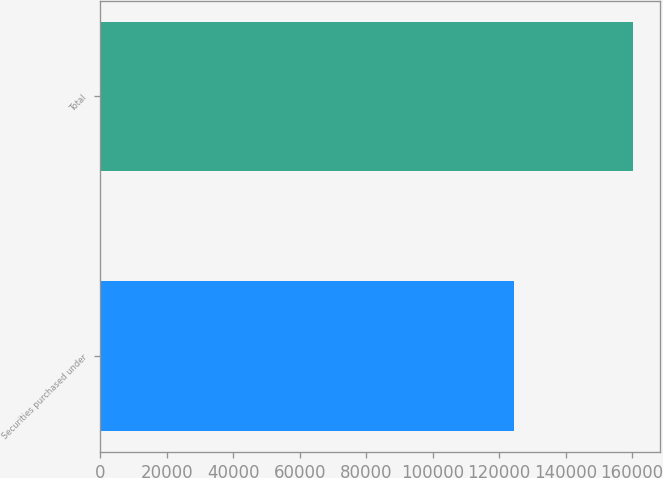Convert chart. <chart><loc_0><loc_0><loc_500><loc_500><bar_chart><fcel>Securities purchased under<fcel>Total<nl><fcel>124557<fcel>160323<nl></chart> 